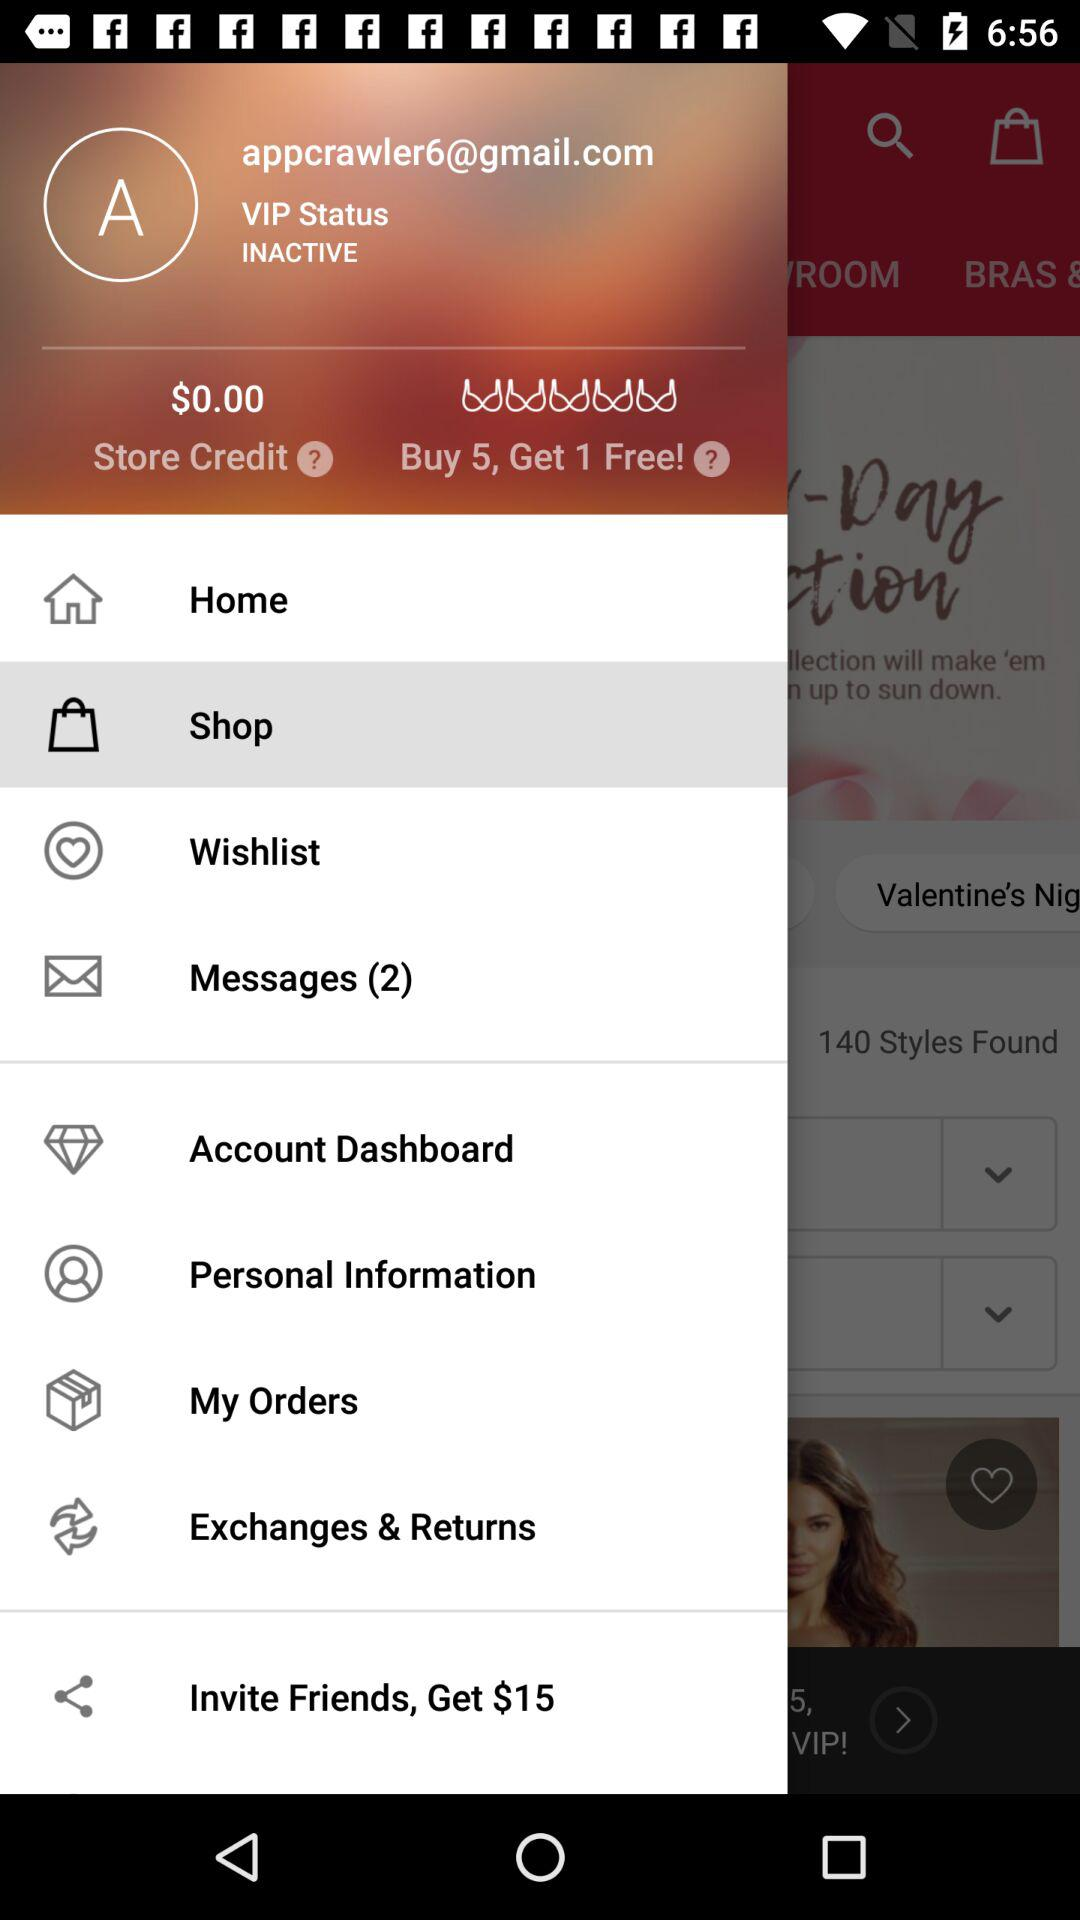What option is selected? The selected option is "Home". 